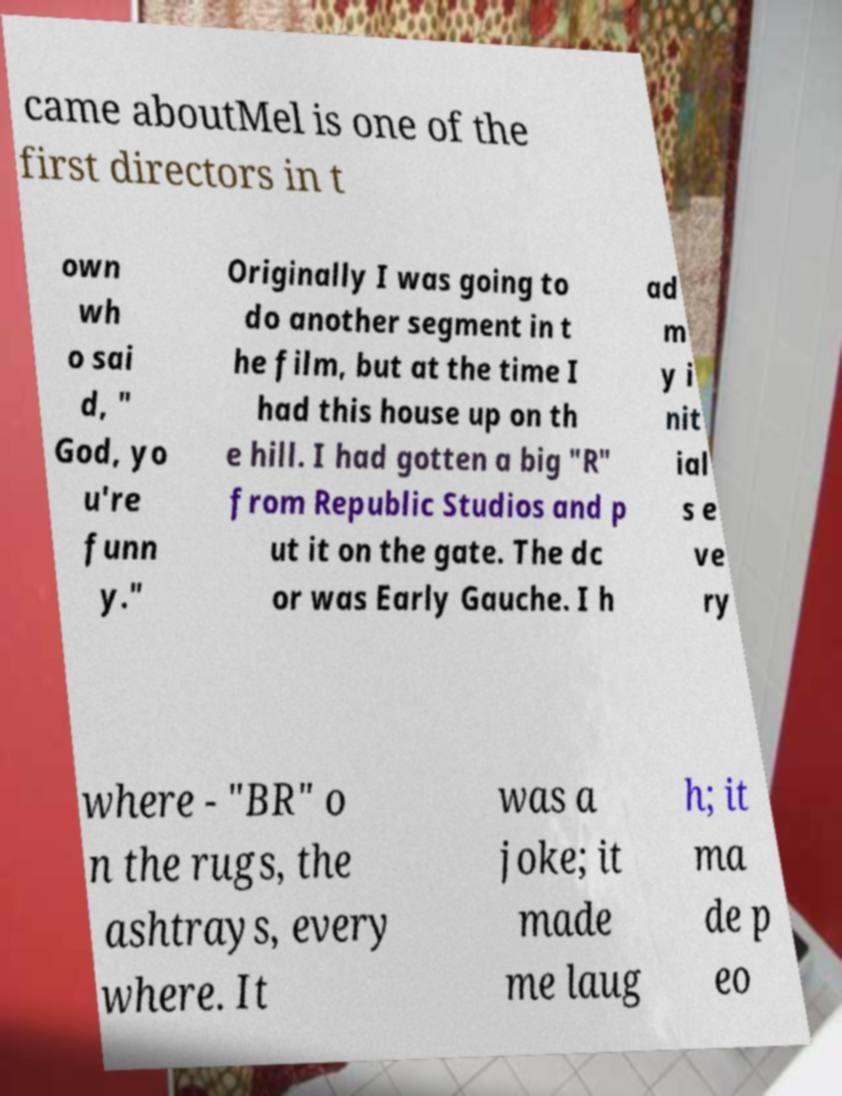There's text embedded in this image that I need extracted. Can you transcribe it verbatim? came aboutMel is one of the first directors in t own wh o sai d, " God, yo u're funn y." Originally I was going to do another segment in t he film, but at the time I had this house up on th e hill. I had gotten a big "R" from Republic Studios and p ut it on the gate. The dc or was Early Gauche. I h ad m y i nit ial s e ve ry where - "BR" o n the rugs, the ashtrays, every where. It was a joke; it made me laug h; it ma de p eo 